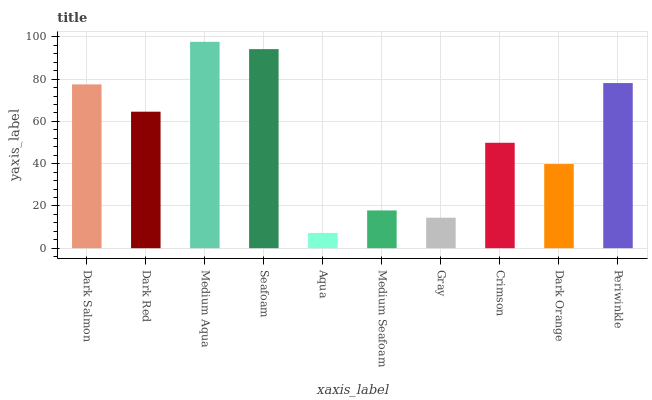Is Dark Red the minimum?
Answer yes or no. No. Is Dark Red the maximum?
Answer yes or no. No. Is Dark Salmon greater than Dark Red?
Answer yes or no. Yes. Is Dark Red less than Dark Salmon?
Answer yes or no. Yes. Is Dark Red greater than Dark Salmon?
Answer yes or no. No. Is Dark Salmon less than Dark Red?
Answer yes or no. No. Is Dark Red the high median?
Answer yes or no. Yes. Is Crimson the low median?
Answer yes or no. Yes. Is Periwinkle the high median?
Answer yes or no. No. Is Dark Salmon the low median?
Answer yes or no. No. 